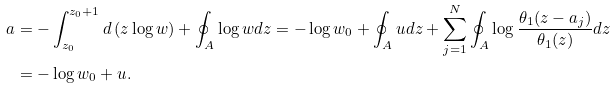<formula> <loc_0><loc_0><loc_500><loc_500>\ a & = - \int _ { z _ { 0 } } ^ { z _ { 0 } + 1 } d \left ( z \log w \right ) + \oint _ { A } \log w d z = - \log w _ { 0 } + \oint _ { A } u d z + \sum _ { j = 1 } ^ { N } \oint _ { A } \log \frac { \theta _ { 1 } ( z - a _ { j } ) } { \theta _ { 1 } ( z ) } d z \\ & = - \log w _ { 0 } + u .</formula> 